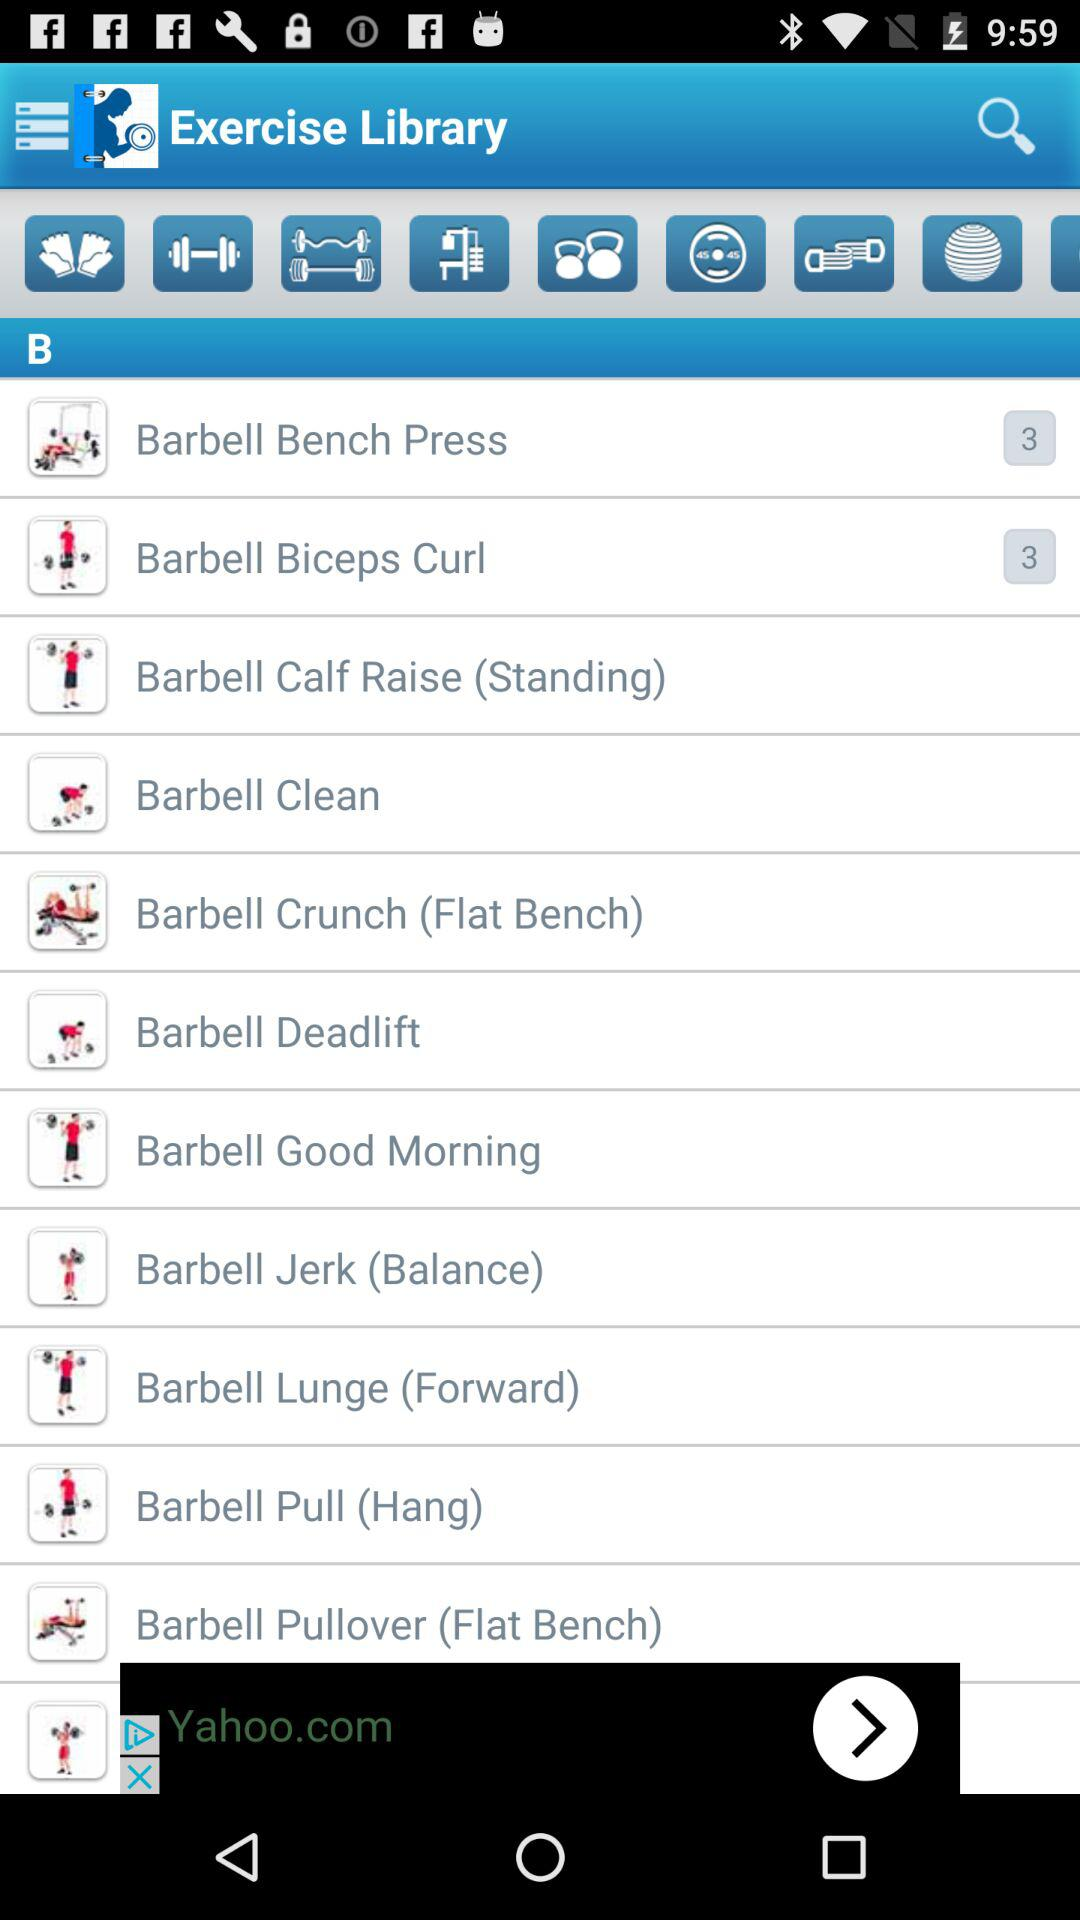What is the number shown for "Barbell Bench Press"? The number shown for "Barbell Bench Press" is 3. 